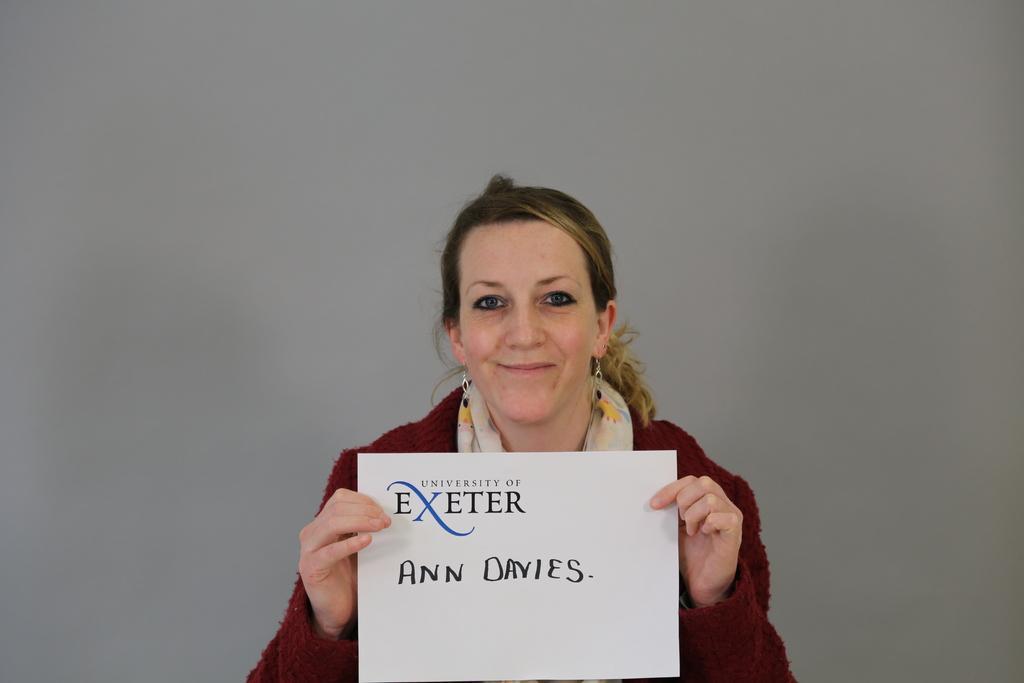In one or two sentences, can you explain what this image depicts? In this picture we can see a woman holding a paper, on which we can see some text. 